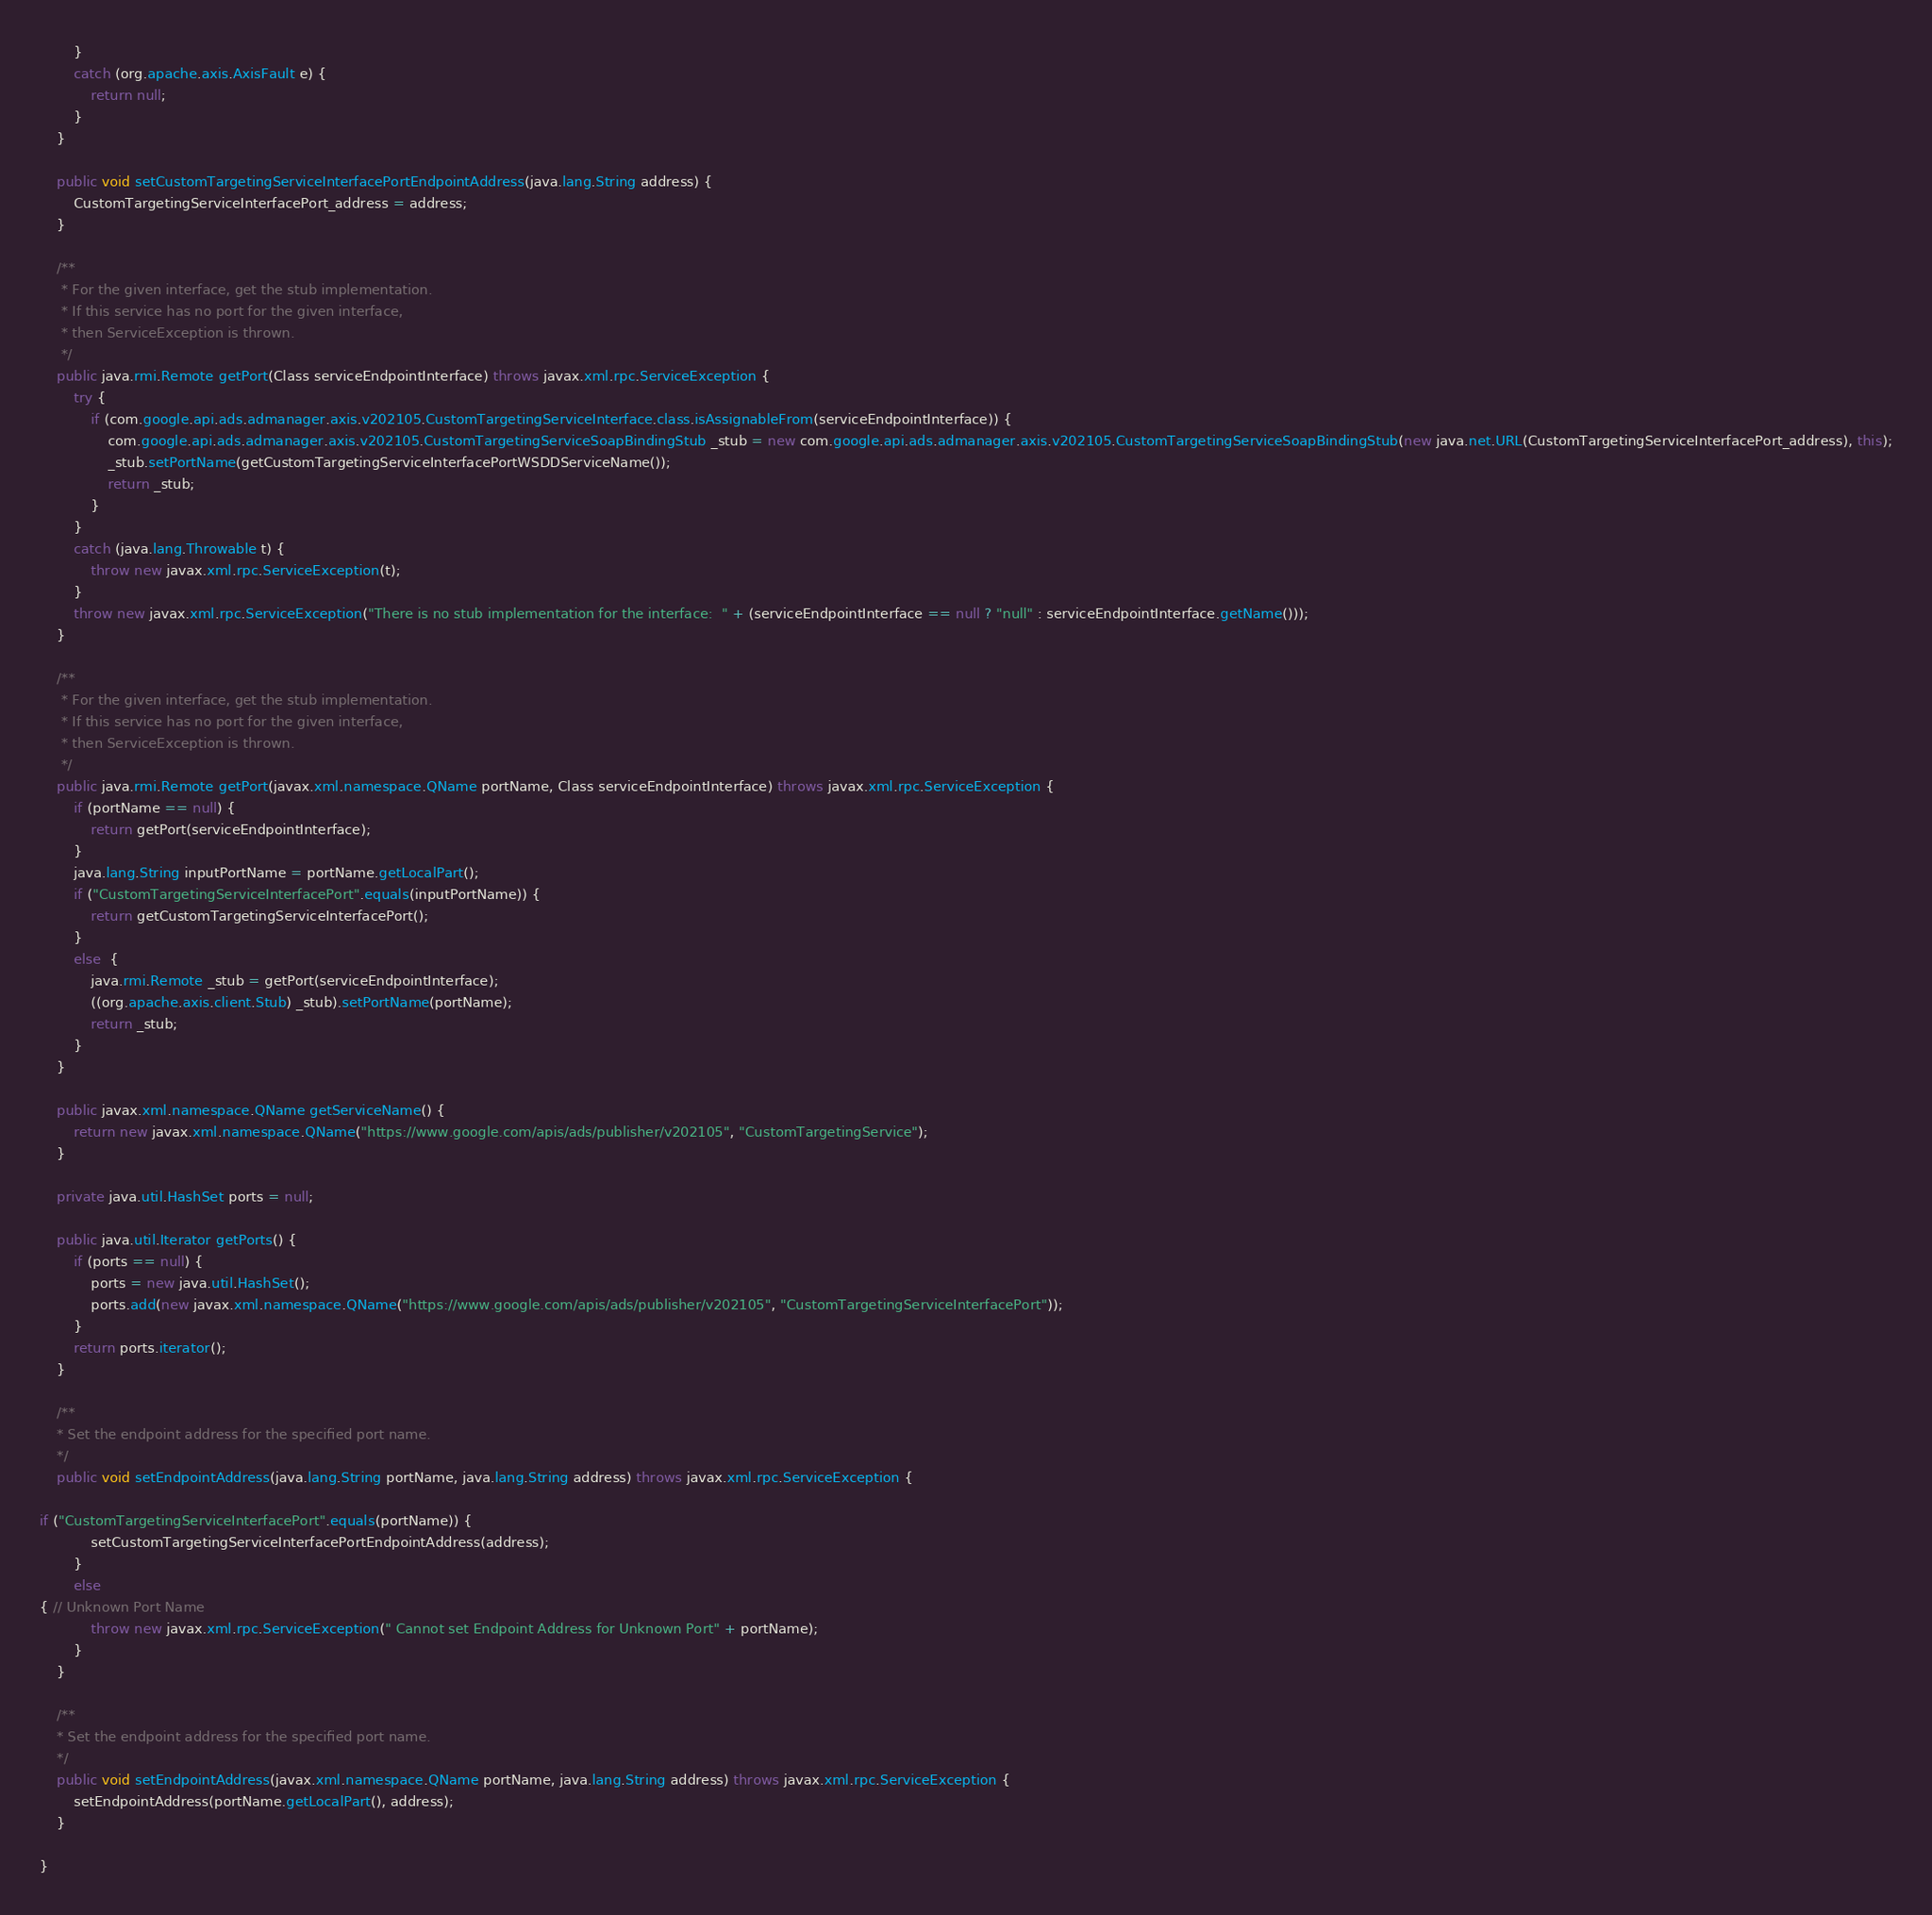<code> <loc_0><loc_0><loc_500><loc_500><_Java_>        }
        catch (org.apache.axis.AxisFault e) {
            return null;
        }
    }

    public void setCustomTargetingServiceInterfacePortEndpointAddress(java.lang.String address) {
        CustomTargetingServiceInterfacePort_address = address;
    }

    /**
     * For the given interface, get the stub implementation.
     * If this service has no port for the given interface,
     * then ServiceException is thrown.
     */
    public java.rmi.Remote getPort(Class serviceEndpointInterface) throws javax.xml.rpc.ServiceException {
        try {
            if (com.google.api.ads.admanager.axis.v202105.CustomTargetingServiceInterface.class.isAssignableFrom(serviceEndpointInterface)) {
                com.google.api.ads.admanager.axis.v202105.CustomTargetingServiceSoapBindingStub _stub = new com.google.api.ads.admanager.axis.v202105.CustomTargetingServiceSoapBindingStub(new java.net.URL(CustomTargetingServiceInterfacePort_address), this);
                _stub.setPortName(getCustomTargetingServiceInterfacePortWSDDServiceName());
                return _stub;
            }
        }
        catch (java.lang.Throwable t) {
            throw new javax.xml.rpc.ServiceException(t);
        }
        throw new javax.xml.rpc.ServiceException("There is no stub implementation for the interface:  " + (serviceEndpointInterface == null ? "null" : serviceEndpointInterface.getName()));
    }

    /**
     * For the given interface, get the stub implementation.
     * If this service has no port for the given interface,
     * then ServiceException is thrown.
     */
    public java.rmi.Remote getPort(javax.xml.namespace.QName portName, Class serviceEndpointInterface) throws javax.xml.rpc.ServiceException {
        if (portName == null) {
            return getPort(serviceEndpointInterface);
        }
        java.lang.String inputPortName = portName.getLocalPart();
        if ("CustomTargetingServiceInterfacePort".equals(inputPortName)) {
            return getCustomTargetingServiceInterfacePort();
        }
        else  {
            java.rmi.Remote _stub = getPort(serviceEndpointInterface);
            ((org.apache.axis.client.Stub) _stub).setPortName(portName);
            return _stub;
        }
    }

    public javax.xml.namespace.QName getServiceName() {
        return new javax.xml.namespace.QName("https://www.google.com/apis/ads/publisher/v202105", "CustomTargetingService");
    }

    private java.util.HashSet ports = null;

    public java.util.Iterator getPorts() {
        if (ports == null) {
            ports = new java.util.HashSet();
            ports.add(new javax.xml.namespace.QName("https://www.google.com/apis/ads/publisher/v202105", "CustomTargetingServiceInterfacePort"));
        }
        return ports.iterator();
    }

    /**
    * Set the endpoint address for the specified port name.
    */
    public void setEndpointAddress(java.lang.String portName, java.lang.String address) throws javax.xml.rpc.ServiceException {
        
if ("CustomTargetingServiceInterfacePort".equals(portName)) {
            setCustomTargetingServiceInterfacePortEndpointAddress(address);
        }
        else 
{ // Unknown Port Name
            throw new javax.xml.rpc.ServiceException(" Cannot set Endpoint Address for Unknown Port" + portName);
        }
    }

    /**
    * Set the endpoint address for the specified port name.
    */
    public void setEndpointAddress(javax.xml.namespace.QName portName, java.lang.String address) throws javax.xml.rpc.ServiceException {
        setEndpointAddress(portName.getLocalPart(), address);
    }

}
</code> 